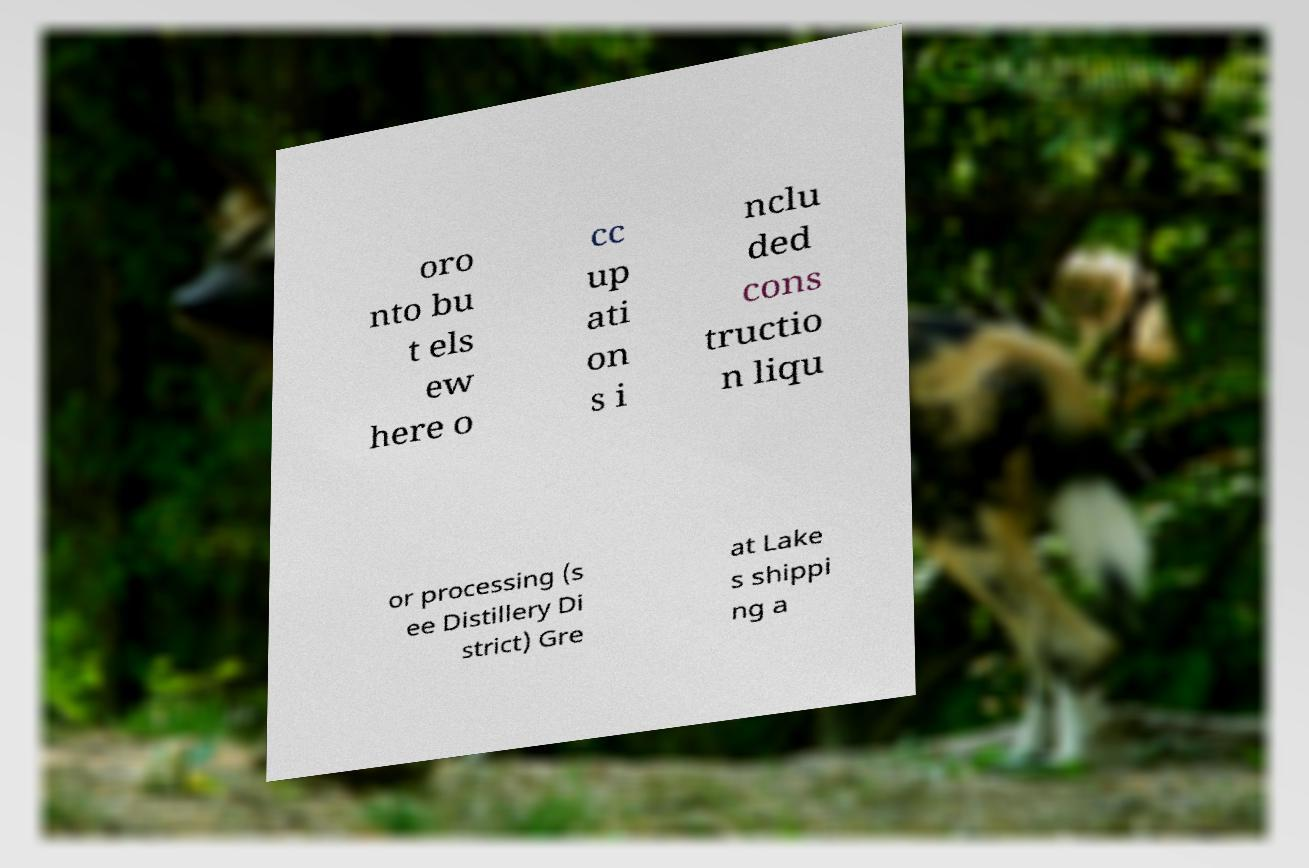I need the written content from this picture converted into text. Can you do that? oro nto bu t els ew here o cc up ati on s i nclu ded cons tructio n liqu or processing (s ee Distillery Di strict) Gre at Lake s shippi ng a 